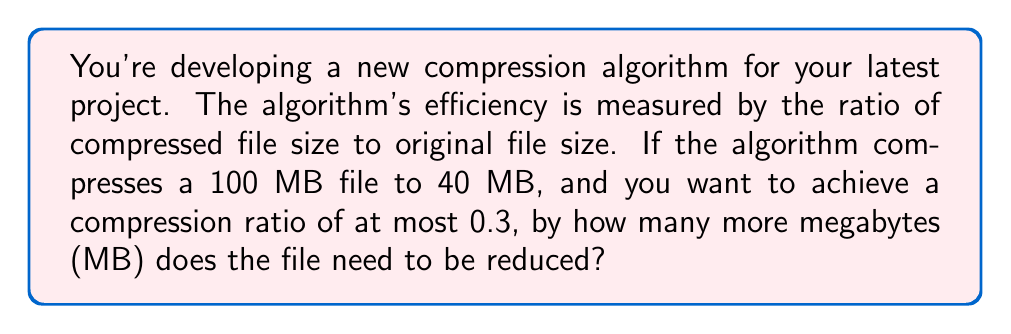Help me with this question. Let's approach this step-by-step:

1) First, let's define our variables:
   $x$ = final compressed size in MB
   $100$ = original file size in MB

2) The current compression ratio is:
   $\frac{40}{100} = 0.4$

3) We want to achieve a ratio of at most 0.3, which means:
   $\frac{x}{100} \leq 0.3$

4) Solving this inequality:
   $x \leq 0.3 \times 100$
   $x \leq 30$

5) This means the file needs to be compressed to 30 MB or less.

6) The current compressed size is 40 MB, so we need to reduce it by:
   $40 - 30 = 10$ MB

Therefore, the file needs to be reduced by at least 10 more megabytes to achieve the desired compression ratio.
Answer: 10 MB 